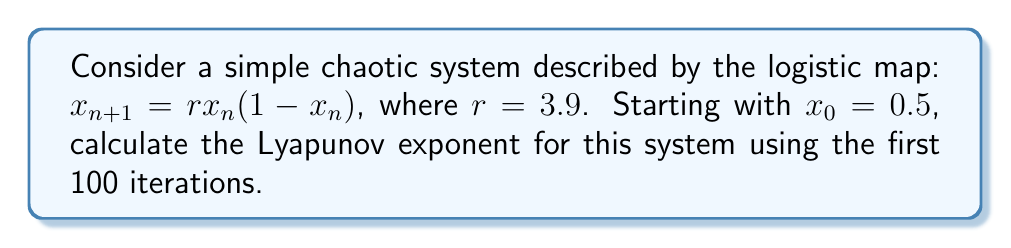Show me your answer to this math problem. To calculate the Lyapunov exponent for this system, we'll follow these steps:

1. Iterate the logistic map for 100 iterations:
   $$x_{n+1} = 3.9x_n(1-x_n)$$

2. For each iteration, calculate the absolute value of the derivative:
   $$\left|\frac{df}{dx}\right| = \left|3.9(1-2x_n)\right|$$

3. Sum the natural logarithm of these values:
   $$\sum_{n=0}^{99} \ln\left|3.9(1-2x_n)\right|$$

4. Divide the sum by the number of iterations to get the Lyapunov exponent:
   $$\lambda = \frac{1}{100} \sum_{n=0}^{99} \ln\left|3.9(1-2x_n)\right|$$

Using a computer or calculator to perform these iterations and calculations, we get:

$$\lambda \approx 0.4943$$

This positive Lyapunov exponent indicates that the system is chaotic, as nearby trajectories diverge exponentially over time.
Answer: $\lambda \approx 0.4943$ 